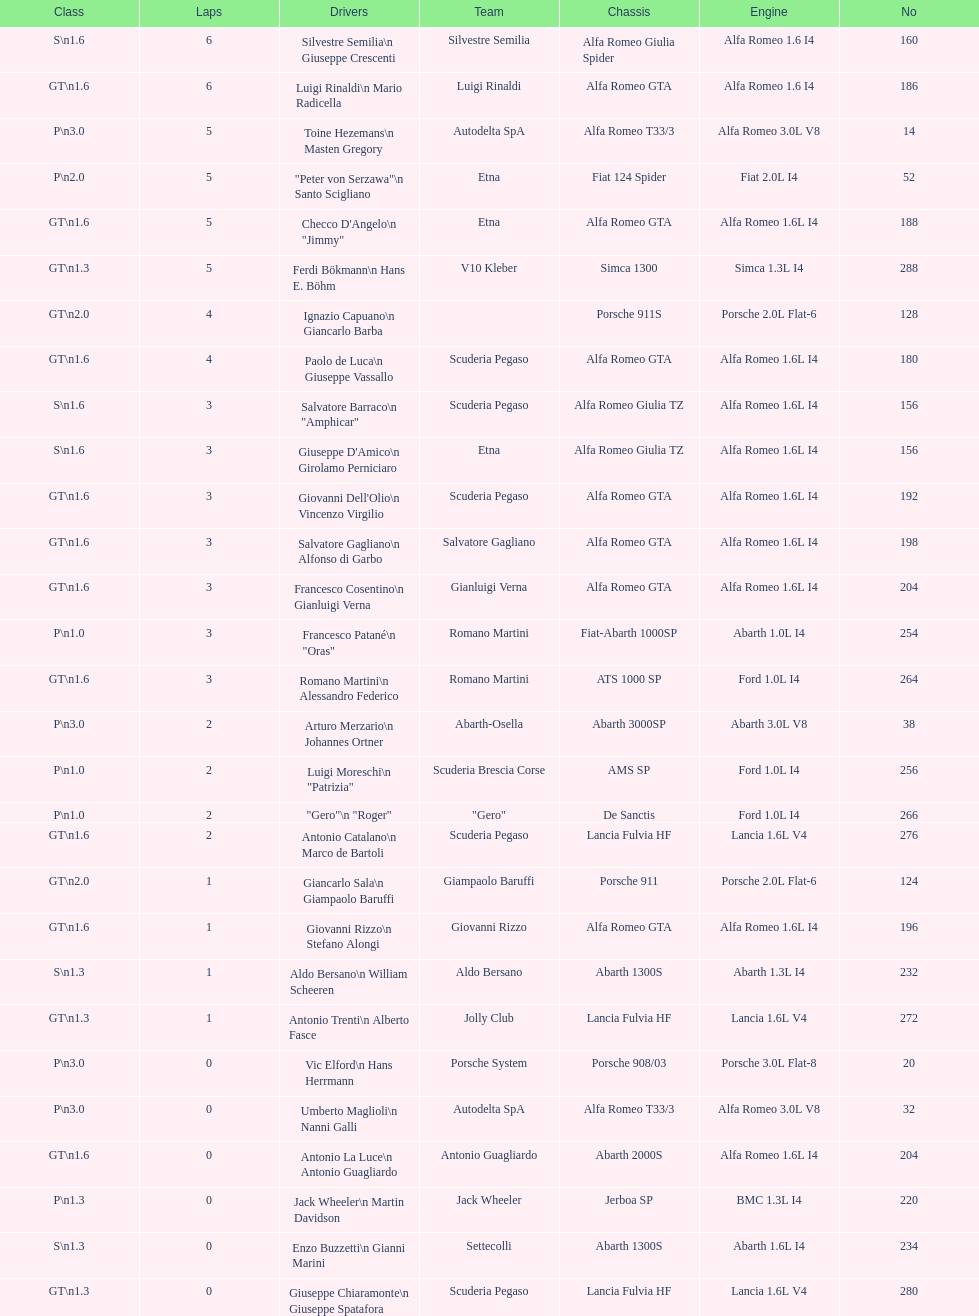How many laps does v10 kleber have? 5. 